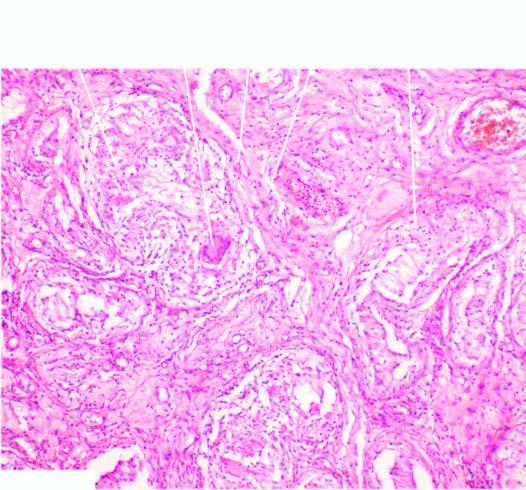re the bronchioles as well as the adjacent alveoli surrounded by langhans 'giant cells and mantle of lymphocytes?
Answer the question using a single word or phrase. No 